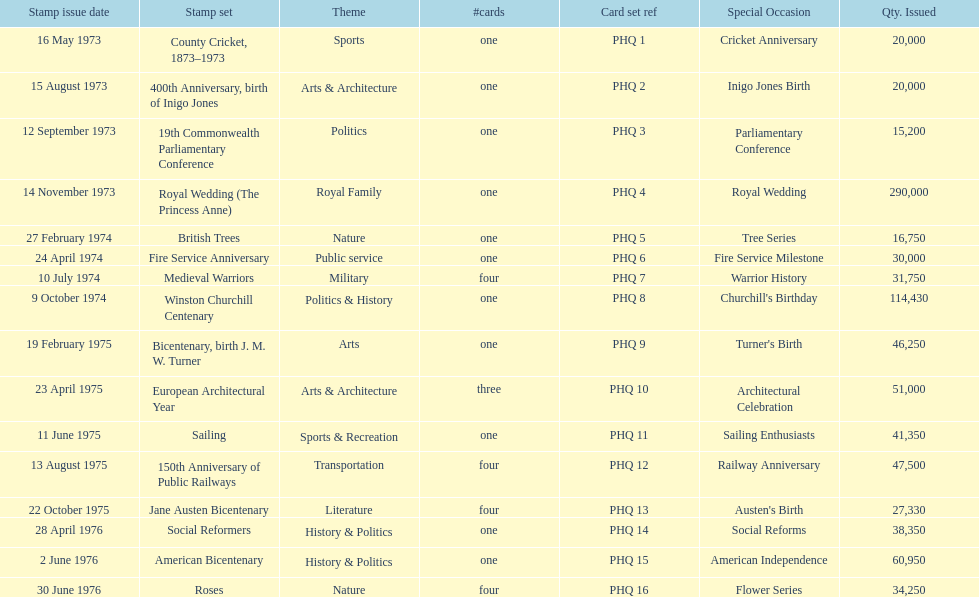List each bicentenary stamp set Bicentenary, birth J. M. W. Turner, Jane Austen Bicentenary, American Bicentenary. 